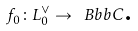Convert formula to latex. <formula><loc_0><loc_0><loc_500><loc_500>f _ { 0 } \colon L _ { 0 } ^ { \vee } \rightarrow \ B b b { C } \text {.}</formula> 